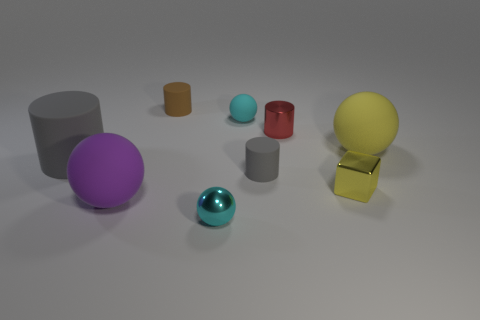Describe the texture of the objects. Are they all the same? The objects exhibit various textures. The brown and cyan cylinders, as well as the gold cube, have a matte finish, while the balls and the gray cylinders seem to have a more reflective or glossy surface. 